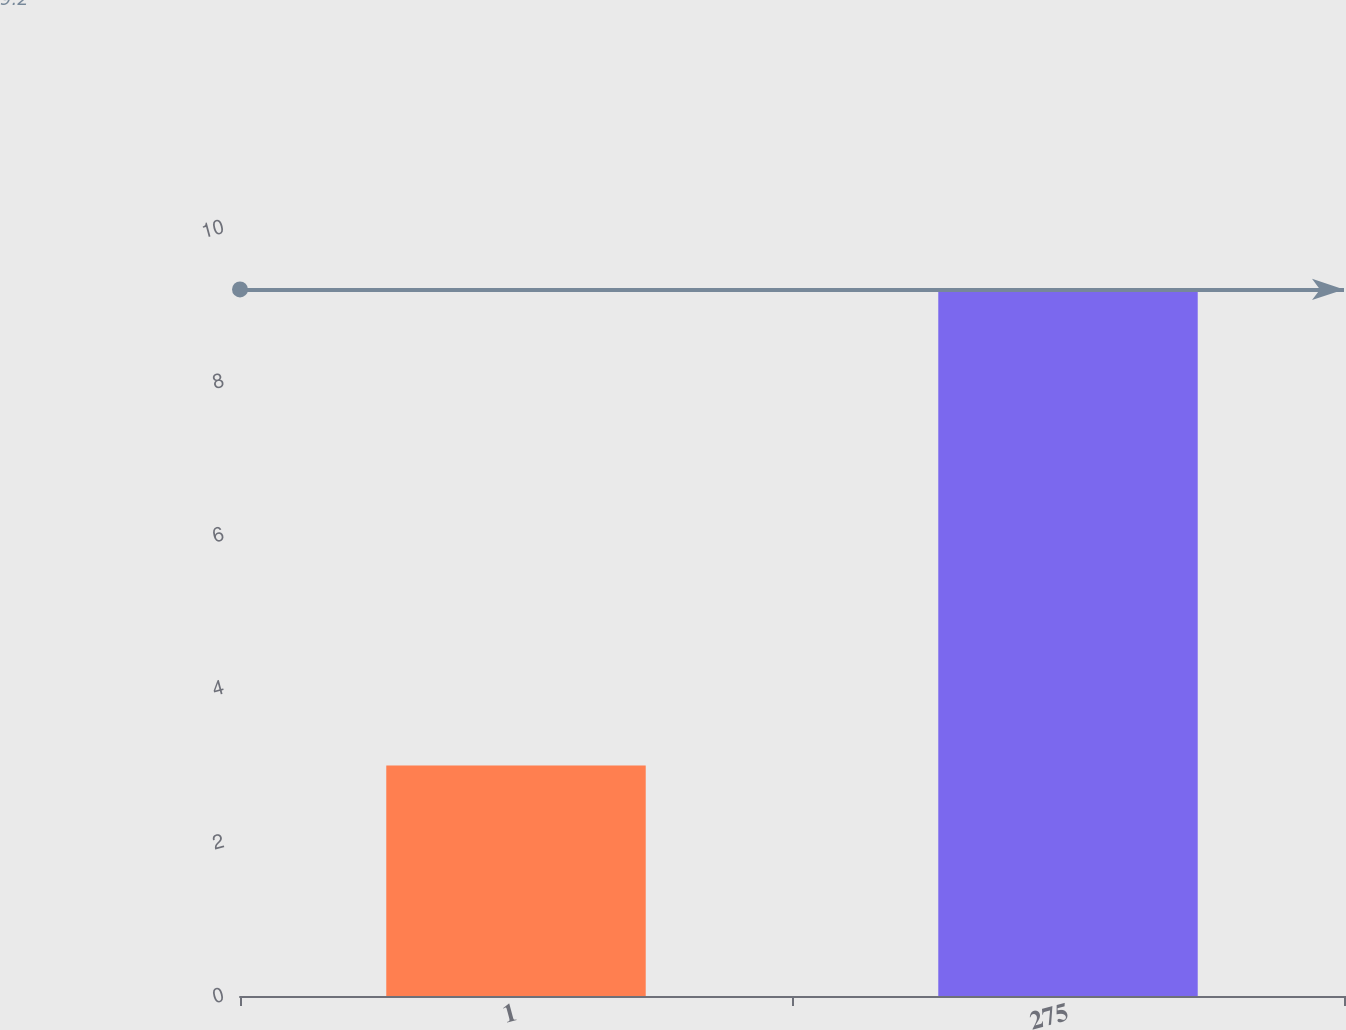<chart> <loc_0><loc_0><loc_500><loc_500><bar_chart><fcel>1<fcel>275<nl><fcel>3<fcel>9.2<nl></chart> 